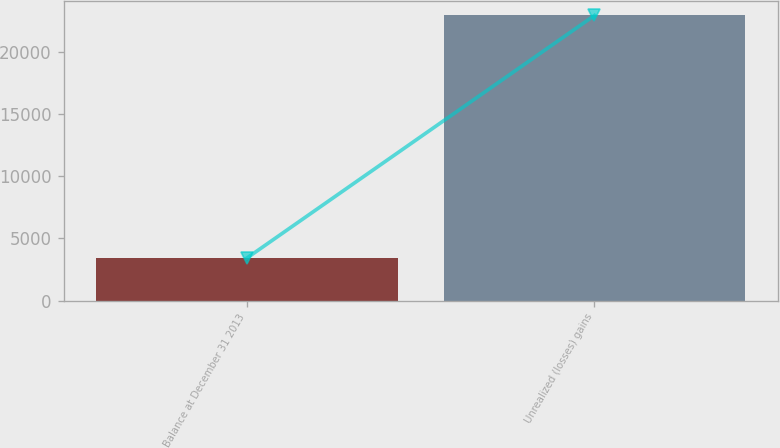Convert chart. <chart><loc_0><loc_0><loc_500><loc_500><bar_chart><fcel>Balance at December 31 2013<fcel>Unrealized (losses) gains<nl><fcel>3421<fcel>22952<nl></chart> 